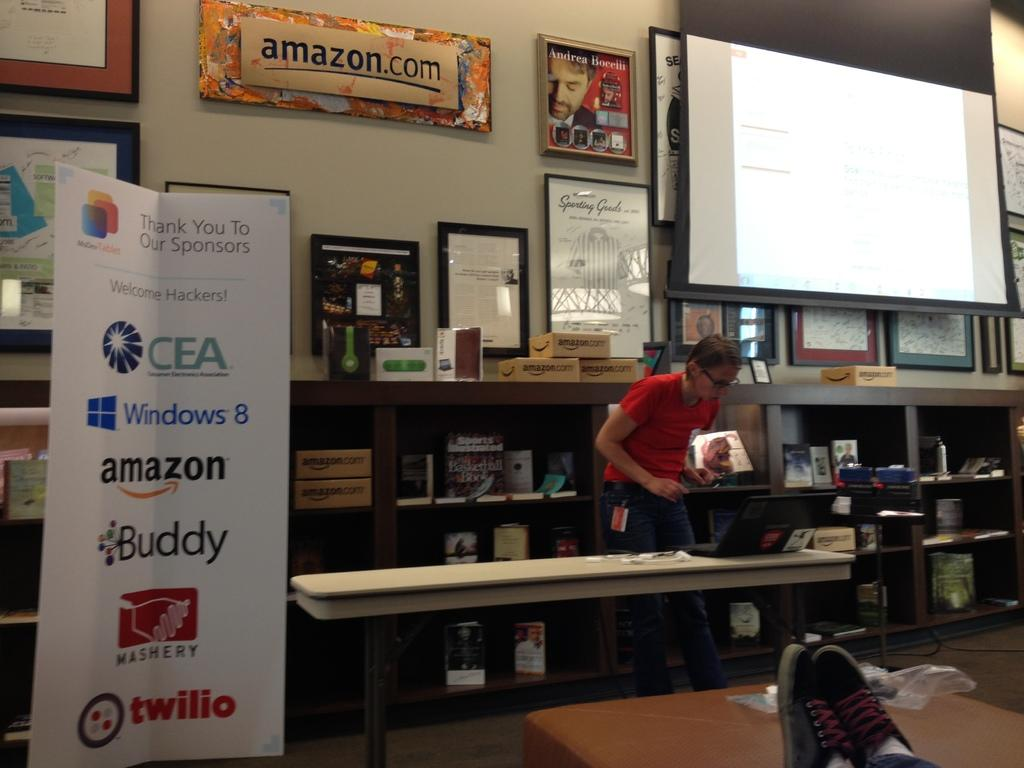What is the woman doing in the image? The woman is standing near the table in the image. What can be seen hanging on the wall? There are photo frames on the wall in the image. What is the large, rectangular object in the image? There is a projector screen in the image. What electronic device is present in the image? There is a laptop in the image. What type of love is being expressed in the image? There is no indication of love or any emotional expression in the image. Can you tell me how many goldfish are swimming in the laptop? There are no goldfish present in the image, and the laptop is not a container for fish. 